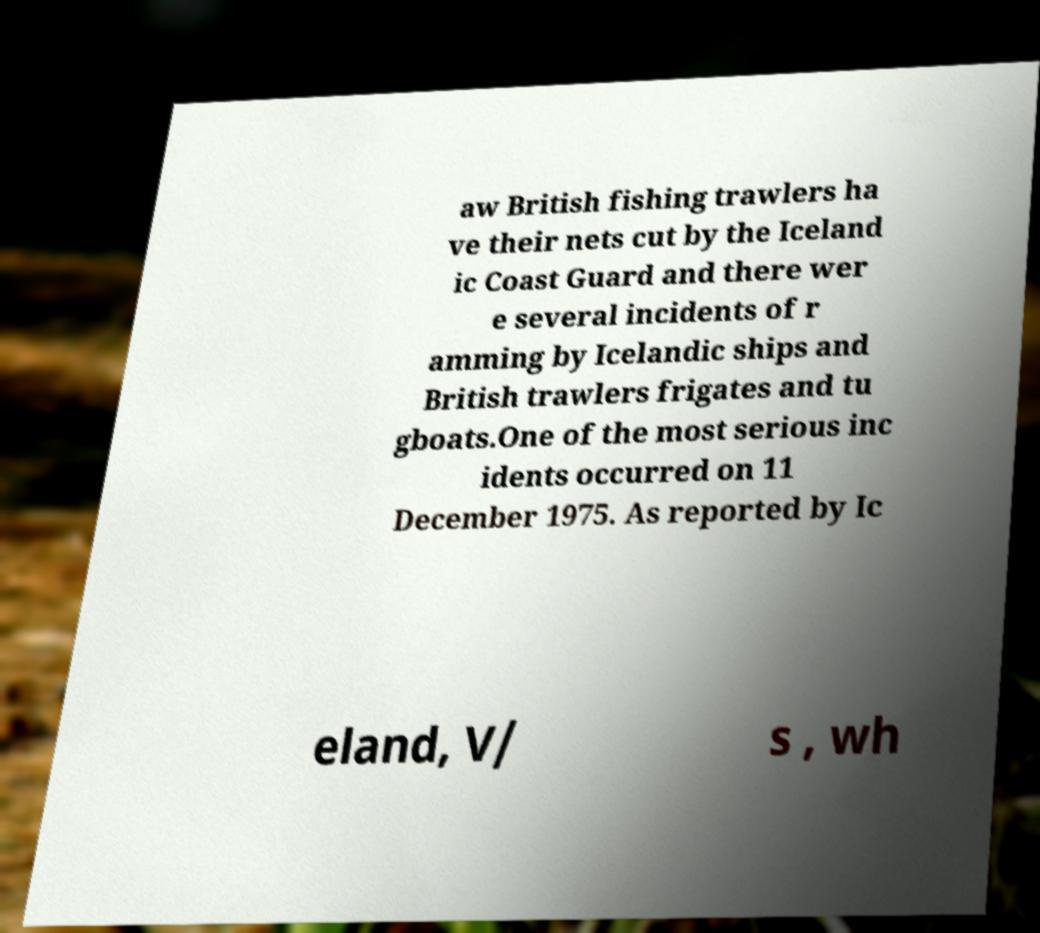Please identify and transcribe the text found in this image. aw British fishing trawlers ha ve their nets cut by the Iceland ic Coast Guard and there wer e several incidents of r amming by Icelandic ships and British trawlers frigates and tu gboats.One of the most serious inc idents occurred on 11 December 1975. As reported by Ic eland, V/ s , wh 